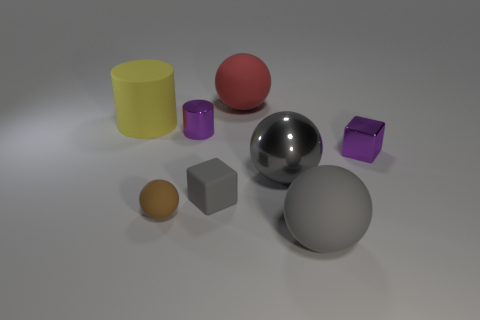There is a purple block that is the same size as the brown rubber sphere; what is its material?
Offer a terse response. Metal. What is the shape of the purple metal object that is the same size as the shiny cube?
Provide a short and direct response. Cylinder. Does the rubber block have the same color as the big matte thing in front of the tiny purple block?
Provide a succinct answer. Yes. Are there any other things that are the same shape as the big yellow object?
Provide a short and direct response. Yes. The large yellow rubber thing has what shape?
Make the answer very short. Cylinder. Do the big gray object behind the small brown object and the red object have the same shape?
Offer a terse response. Yes. Is the number of gray blocks that are left of the tiny shiny cube greater than the number of tiny rubber spheres behind the brown matte thing?
Provide a succinct answer. Yes. Does the big yellow object have the same shape as the purple metallic thing on the left side of the metallic block?
Your answer should be very brief. Yes. How many matte objects are purple objects or large red things?
Your answer should be compact. 1. Are there any other objects that have the same color as the big metallic object?
Offer a very short reply. Yes. 